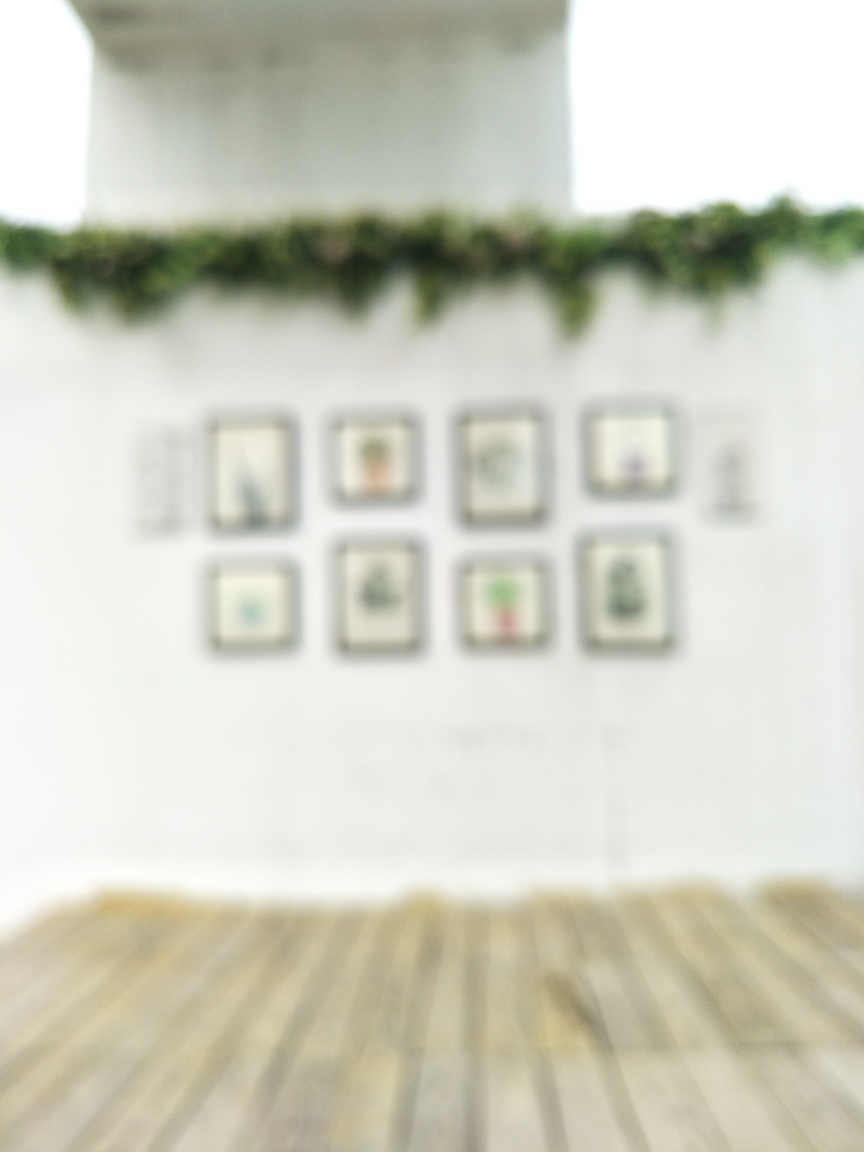What might be the reasons for intentionally using a blurred image in a presentation or artwork? Blurred images are often used to convey a sense of motion, create an atmosphere of mystery or nostalgia, or focus attention on other elements of the artwork or presentation by softening the background or less relevant details. 